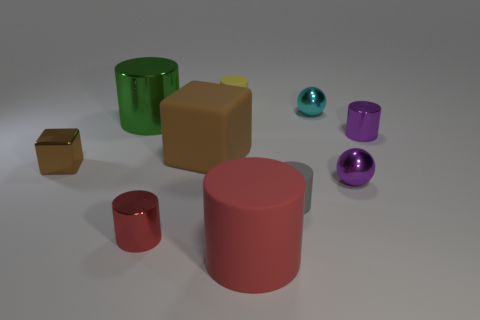Subtract 2 cylinders. How many cylinders are left? 4 Subtract all purple metal cylinders. How many cylinders are left? 5 Subtract all green cylinders. How many cylinders are left? 5 Subtract all brown cylinders. Subtract all green blocks. How many cylinders are left? 6 Subtract all cylinders. How many objects are left? 4 Subtract 1 cyan spheres. How many objects are left? 9 Subtract all red objects. Subtract all big green shiny cylinders. How many objects are left? 7 Add 1 small gray things. How many small gray things are left? 2 Add 5 tiny spheres. How many tiny spheres exist? 7 